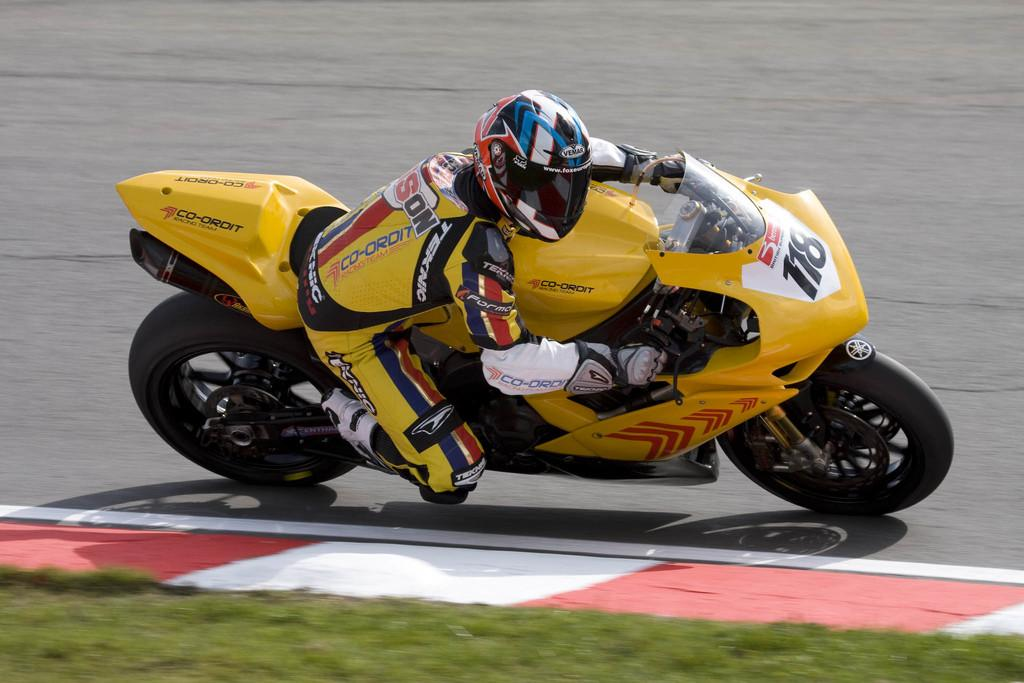What is the main subject of the image? The main subject of the image is a biker. What is the biker doing in the image? The biker is riding a bike in the image. Where is the biker riding the bike? The biker is on a track in the image. What can be seen beside the track? There is grass beside the track in the image. Does the biker's sister appear in the image? There is no mention of a sister in the image, so it cannot be determined if she is present. 